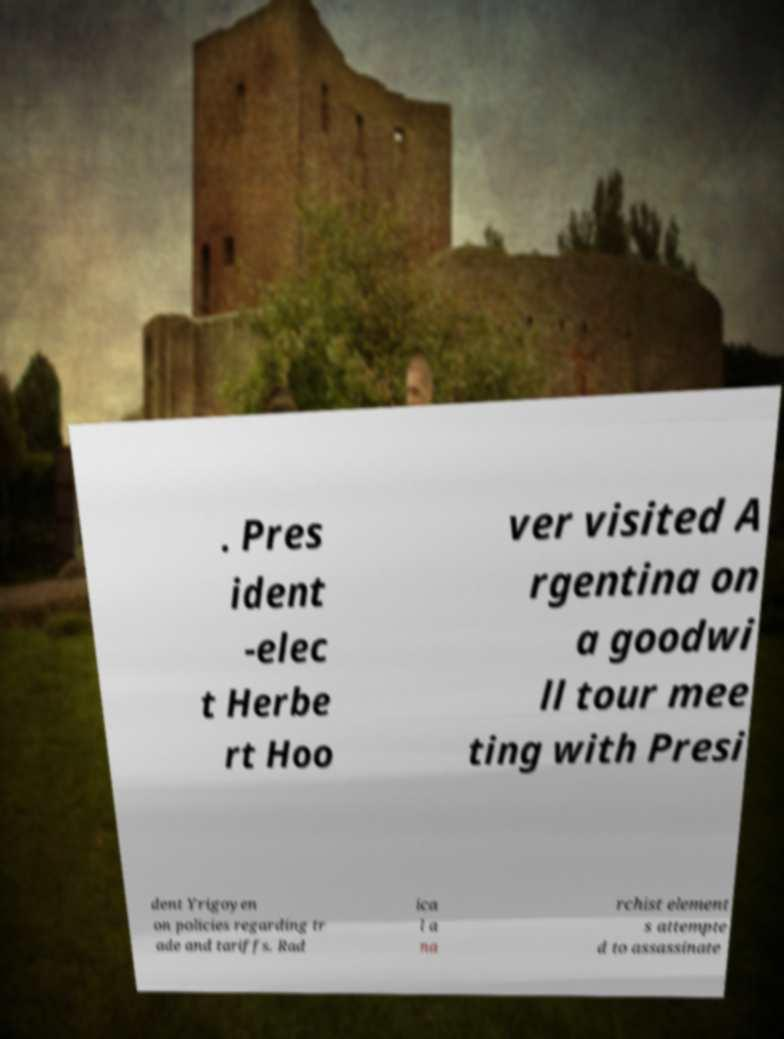For documentation purposes, I need the text within this image transcribed. Could you provide that? . Pres ident -elec t Herbe rt Hoo ver visited A rgentina on a goodwi ll tour mee ting with Presi dent Yrigoyen on policies regarding tr ade and tariffs. Rad ica l a na rchist element s attempte d to assassinate 